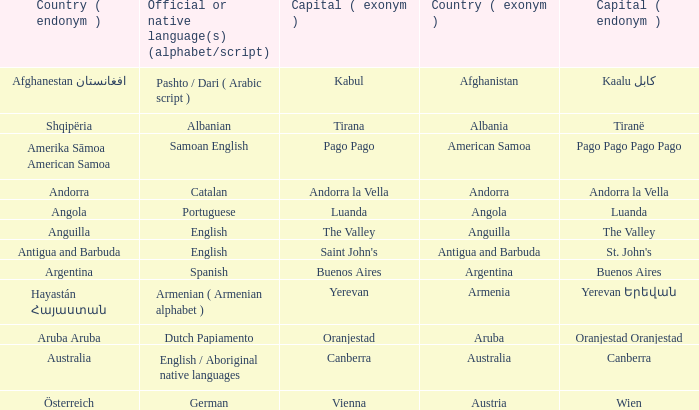What is the local name given to the capital of Anguilla? The Valley. 